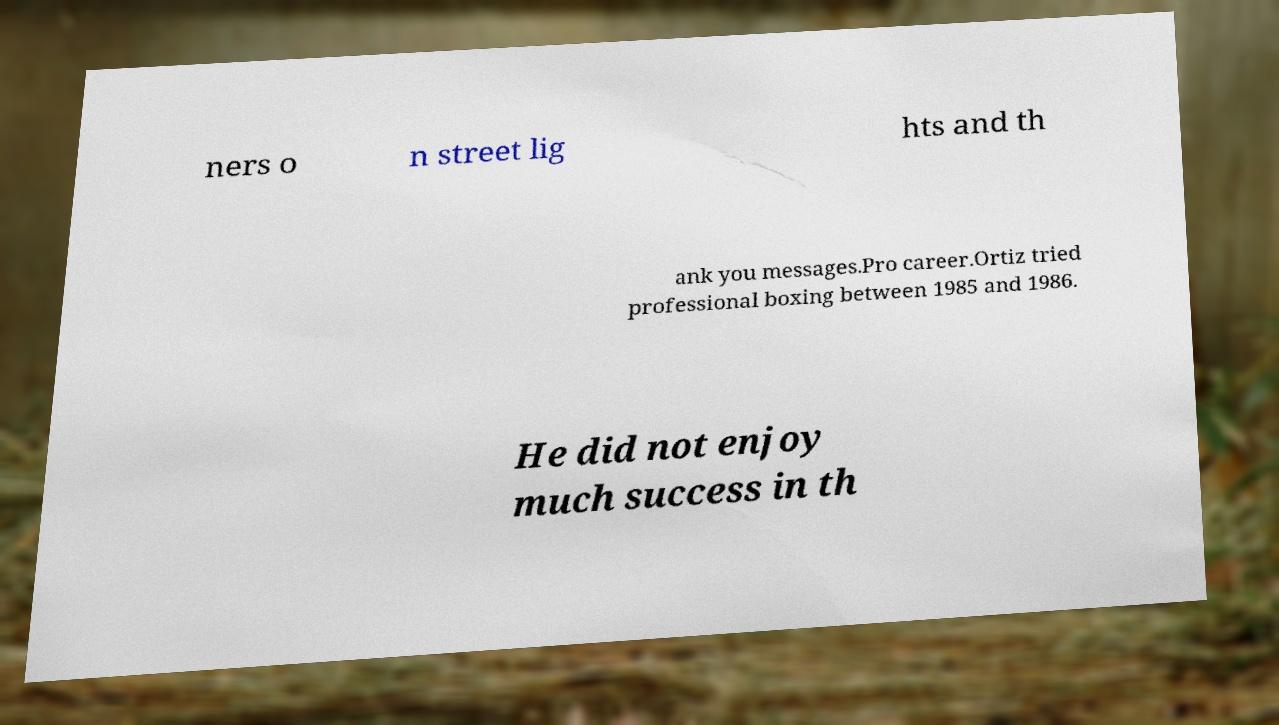Please identify and transcribe the text found in this image. ners o n street lig hts and th ank you messages.Pro career.Ortiz tried professional boxing between 1985 and 1986. He did not enjoy much success in th 